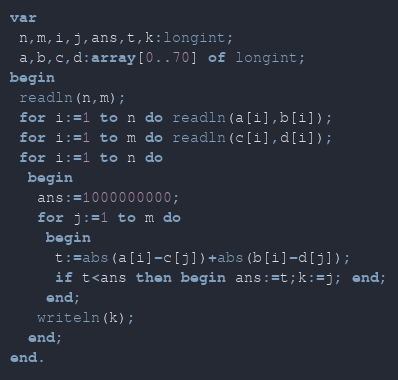Convert code to text. <code><loc_0><loc_0><loc_500><loc_500><_Pascal_>var
 n,m,i,j,ans,t,k:longint;
 a,b,c,d:array[0..70] of longint;
begin
 readln(n,m);
 for i:=1 to n do readln(a[i],b[i]);
 for i:=1 to m do readln(c[i],d[i]);
 for i:=1 to n do
  begin
   ans:=1000000000;
   for j:=1 to m do
    begin
     t:=abs(a[i]-c[j])+abs(b[i]-d[j]);
     if t<ans then begin ans:=t;k:=j; end;
    end;
   writeln(k);
  end;
end.</code> 